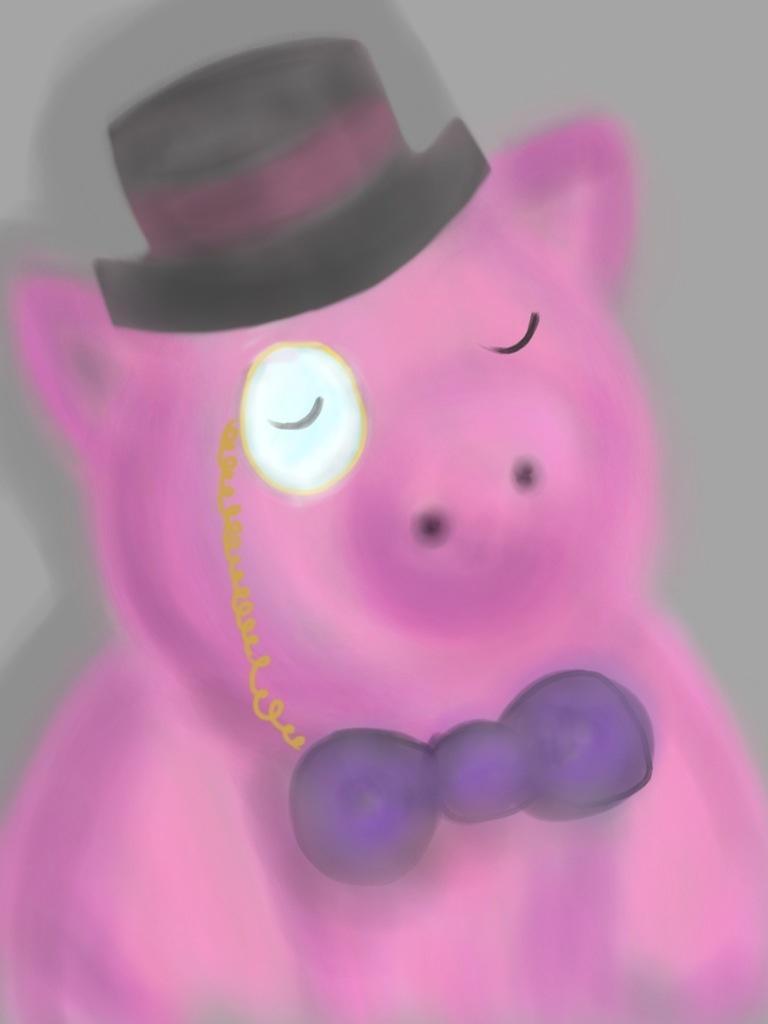Describe this image in one or two sentences. This image consists of a pig. It looks like a painting. It is in pink color. At the top, there is a hat. 